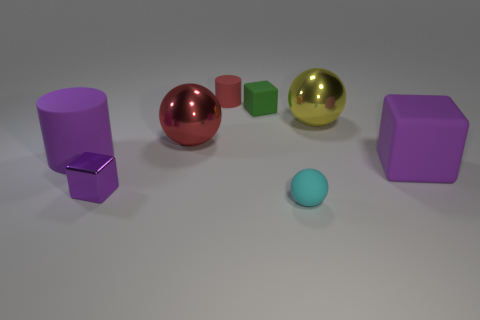Add 1 matte blocks. How many objects exist? 9 Subtract all balls. How many objects are left? 5 Subtract 1 green cubes. How many objects are left? 7 Subtract all purple matte objects. Subtract all balls. How many objects are left? 3 Add 2 red balls. How many red balls are left? 3 Add 2 rubber cubes. How many rubber cubes exist? 4 